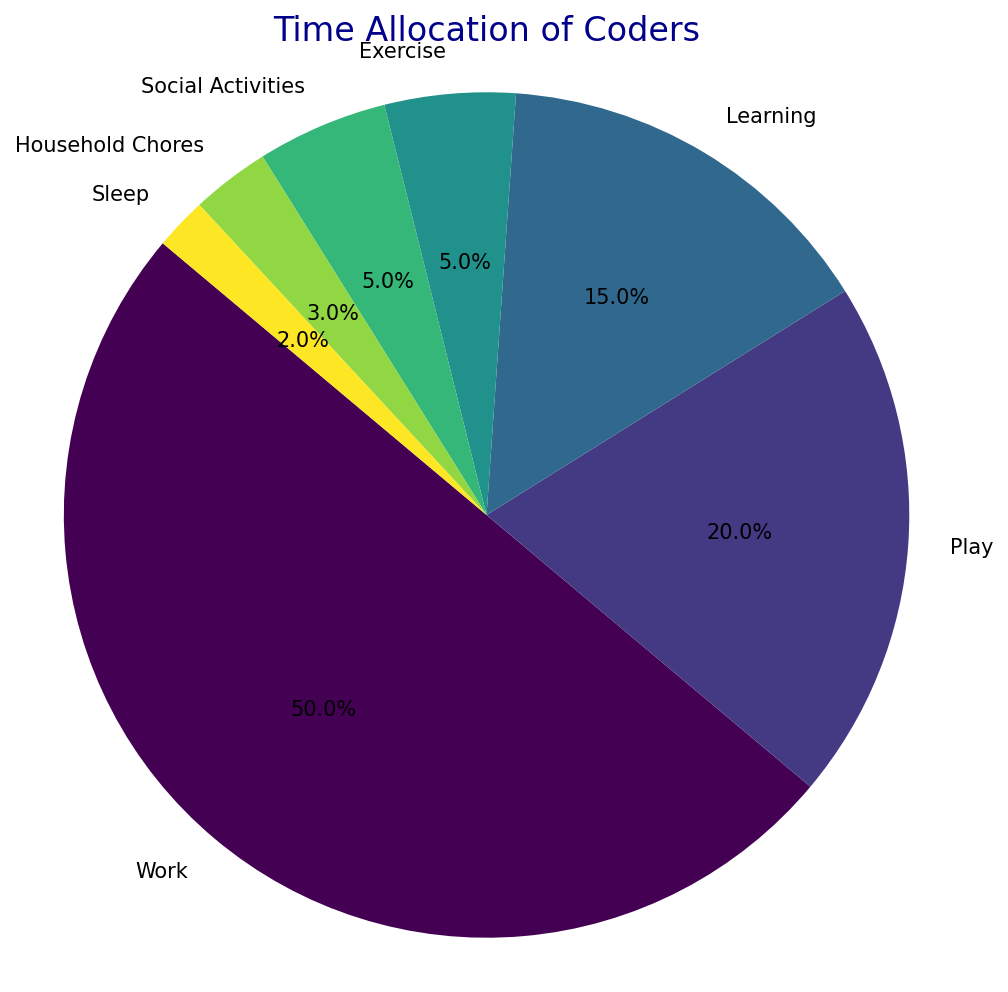What percentage of time do coders spend on social activities? Social Activities is labeled with 5% on the pie chart.
Answer: 5% Which activity do coders spend the most time on? The Work slice of the pie chart is the largest with a percentage of 50%.
Answer: Work How much more time do coders spend on Work compared to Play? Work is 50% and Play is 20%, so the difference is 50% - 20% = 30%.
Answer: 30% What combined percentage of time do coders spend on Learning, Exercise, and Household Chores? The percentages are 15% for Learning, 5% for Exercise, and 3% for Household Chores. Adding them gives 15% + 5% + 3% = 23%.
Answer: 23% Which slice has the smallest percentage and what is it? The Sleep slice is the smallest with a percentage of 2%.
Answer: Sleep Do coders spend more time on Exercise or Household Chores, and by how much? Exercise is 5% and Household Chores is 3%. The difference is 5% - 3% = 2%.
Answer: Exercise by 2% What is the total percentage of time coders spend on activities other than Work and Sleep? The total percentage is 100%, subtracting Work (50%) and Sleep (2%) gives 100% - 50% - 2% = 48%.
Answer: 48% If Social Activities and Household Chores are combined into a single category, what percentage of the pie chart would that category represent? Social Activities is 5% and Household Chores is 3%. Combined, they are 5% + 3% = 8%.
Answer: 8% What is the difference in percentage between the time allocated to Learning and Sleep? Learning is 15% and Sleep is 2%. The difference is 15% - 2% = 13%.
Answer: 13% How much more time do coders spend on Play compared to Learning, Exercise, and Household Chores combined? Play is 20%. Learning, Exercise, and Household Chores combined is 23%. The difference is 20% - 23% = -3%.
Answer: 3% less 